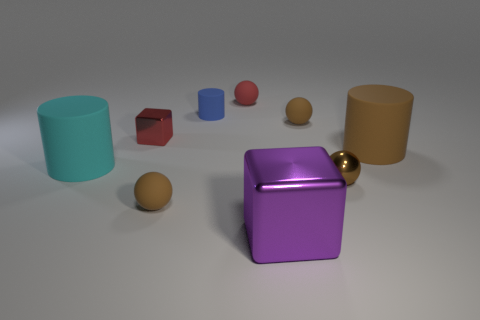Subtract all red balls. How many balls are left? 3 Subtract all large cylinders. How many cylinders are left? 1 Subtract all red cylinders. How many brown balls are left? 3 Subtract all gray spheres. Subtract all red cylinders. How many spheres are left? 4 Subtract all cubes. How many objects are left? 7 Add 3 cubes. How many cubes exist? 5 Subtract 0 green balls. How many objects are left? 9 Subtract all large brown matte cylinders. Subtract all tiny brown metal spheres. How many objects are left? 7 Add 7 cyan objects. How many cyan objects are left? 8 